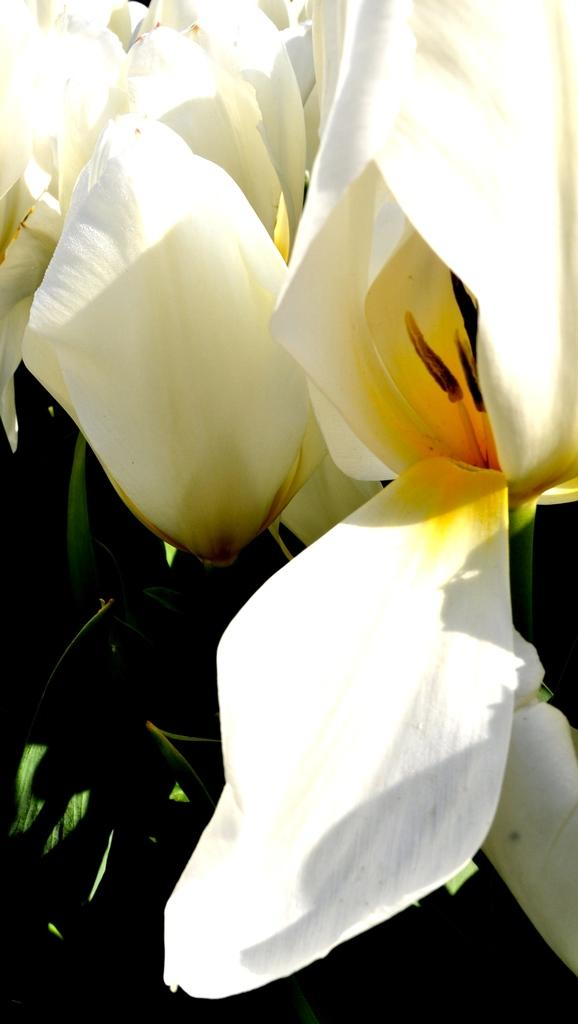What is the main subject of the image? The main subject of the image is a close-up of flowers. What can be inferred about the flowers in the image? The flowers belong to a plant. What type of glue is being used to hold the giraffe in the image? There is no giraffe present in the image, and therefore no glue or any related activity can be observed. 